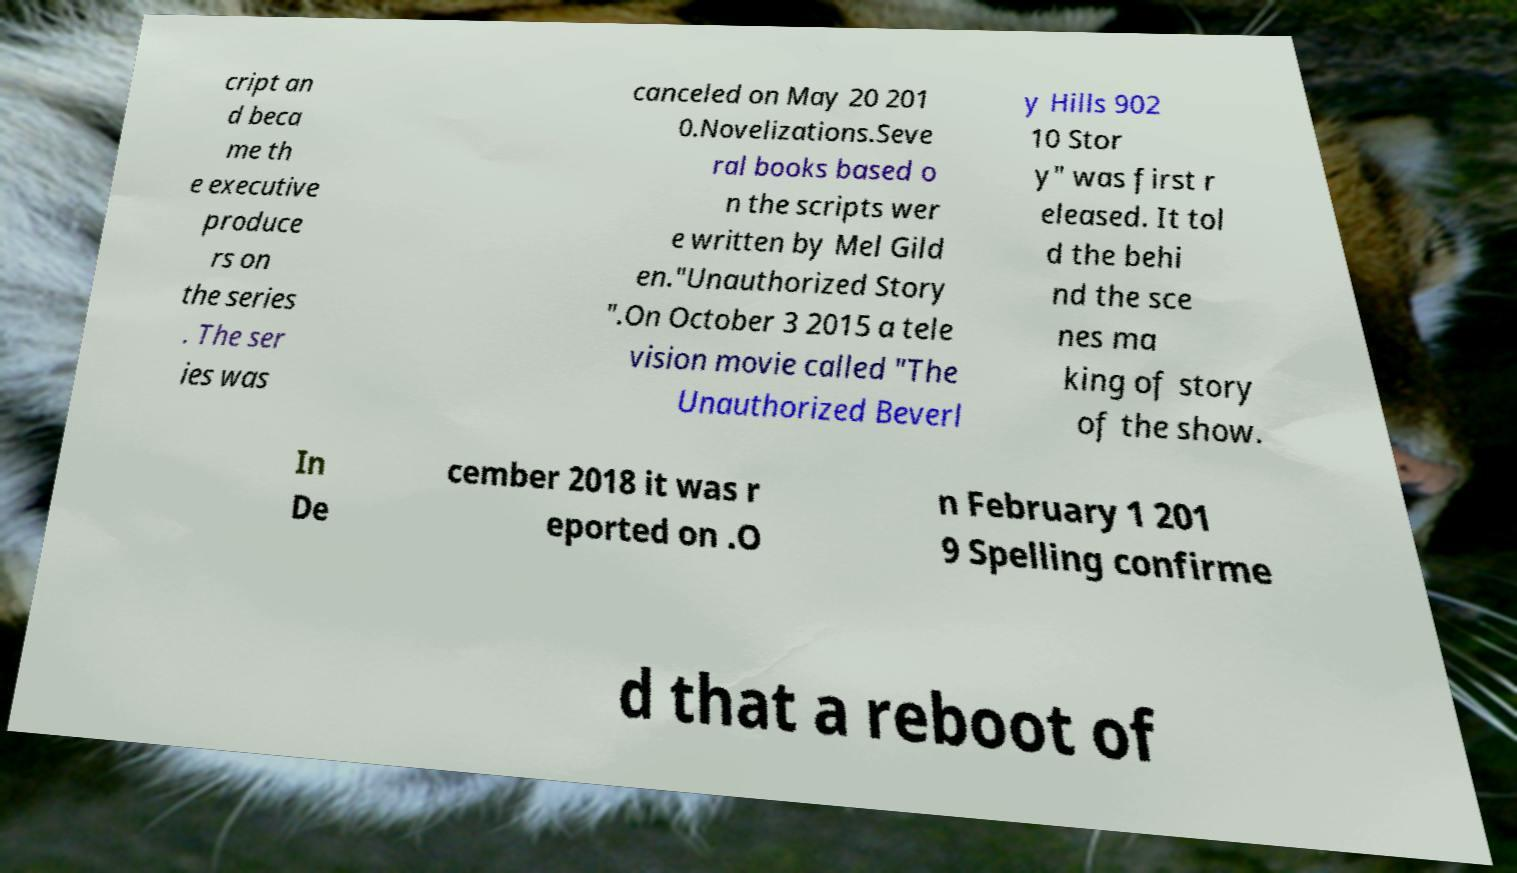For documentation purposes, I need the text within this image transcribed. Could you provide that? cript an d beca me th e executive produce rs on the series . The ser ies was canceled on May 20 201 0.Novelizations.Seve ral books based o n the scripts wer e written by Mel Gild en."Unauthorized Story ".On October 3 2015 a tele vision movie called "The Unauthorized Beverl y Hills 902 10 Stor y" was first r eleased. It tol d the behi nd the sce nes ma king of story of the show. In De cember 2018 it was r eported on .O n February 1 201 9 Spelling confirme d that a reboot of 